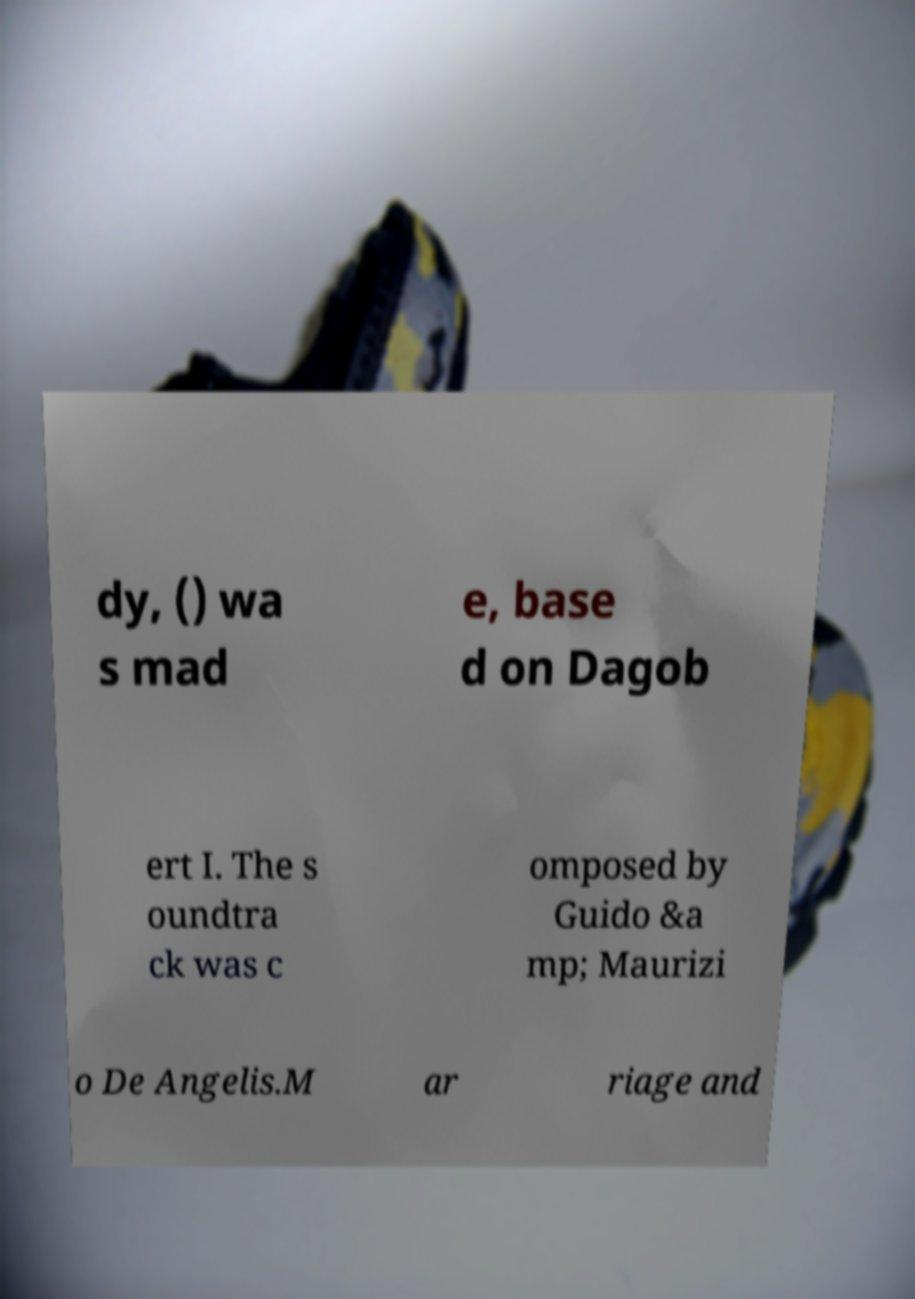Can you read and provide the text displayed in the image?This photo seems to have some interesting text. Can you extract and type it out for me? dy, () wa s mad e, base d on Dagob ert I. The s oundtra ck was c omposed by Guido &a mp; Maurizi o De Angelis.M ar riage and 